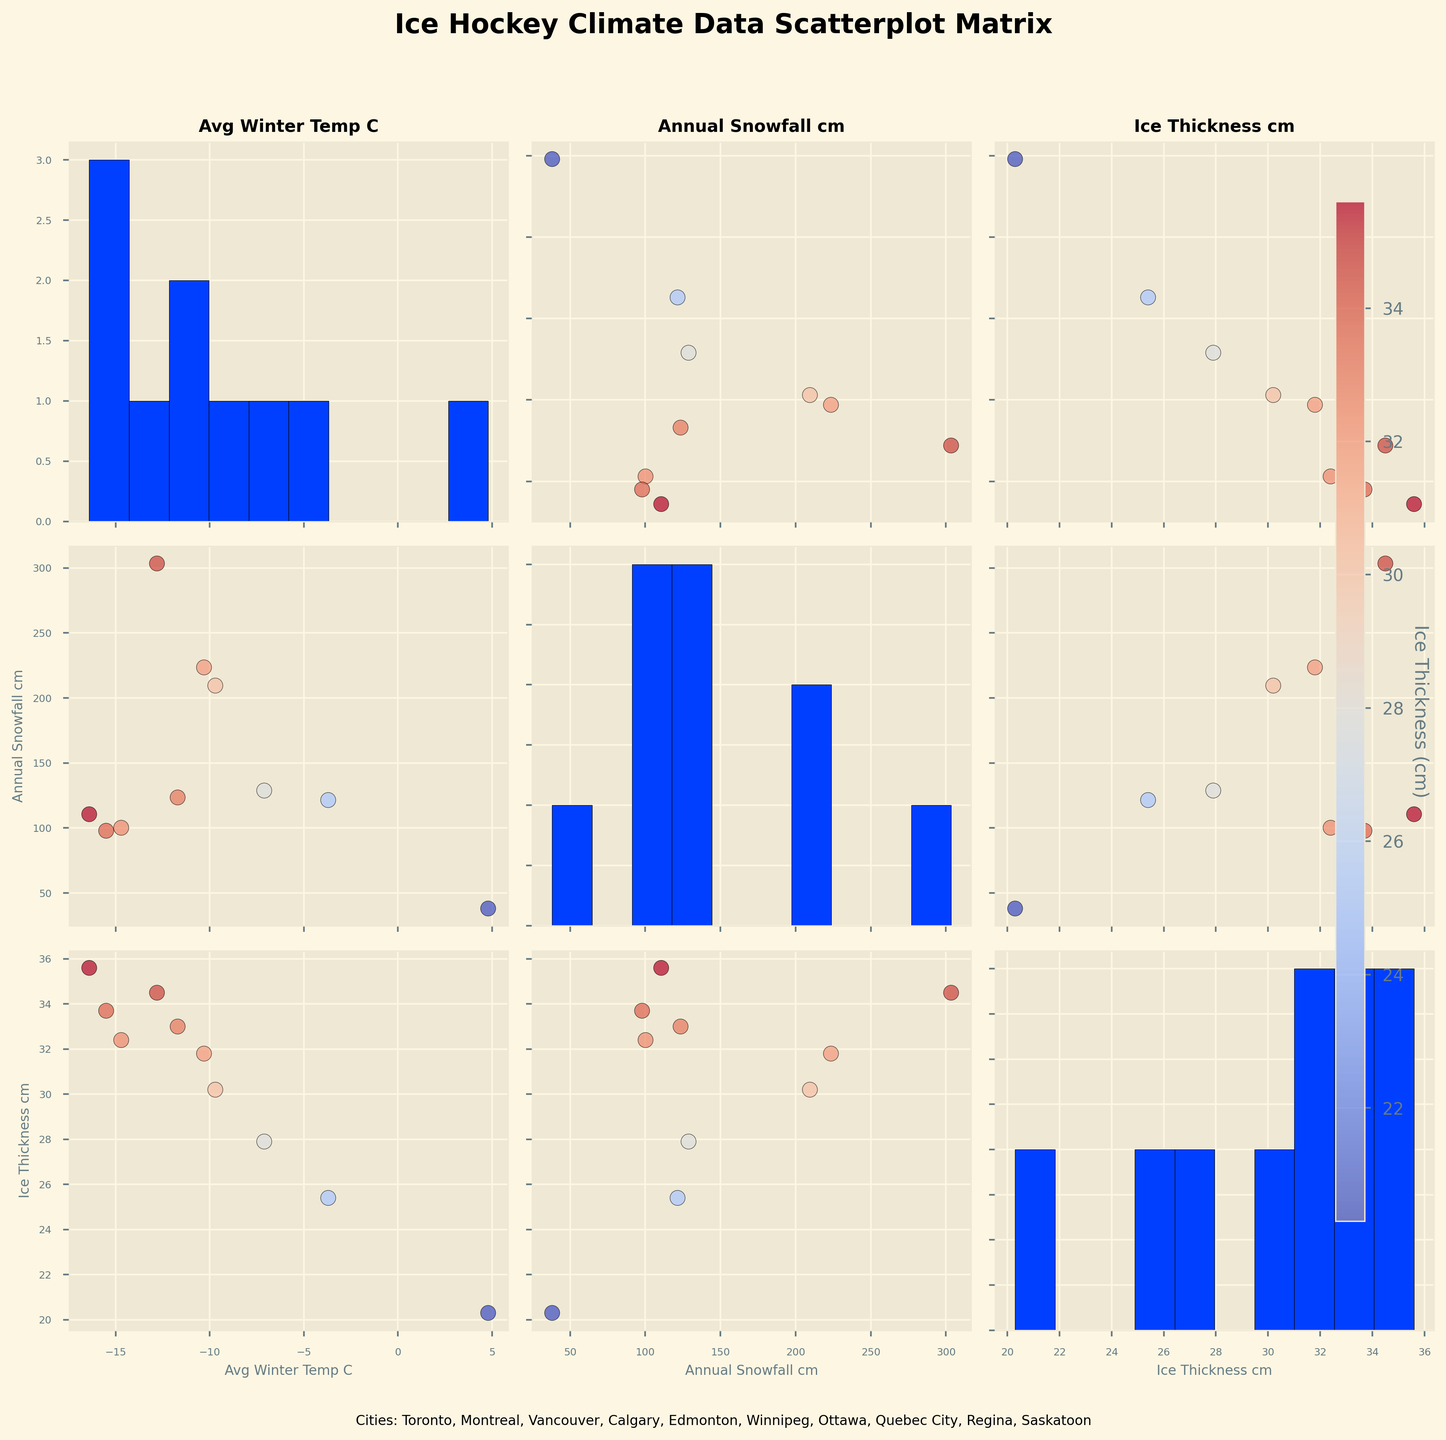What is the title of this figure? The figure title is generally located at the top of the plot and in this case, "Ice Hockey Climate Data Scatterplot Matrix" should be written there.
Answer: Ice Hockey Climate Data Scatterplot Matrix How many variables are displayed in the scatterplot matrix? The matrix plots relationships between three variables, as indicated by the labels on the axes: Avg Winter Temp (C), Annual Snowfall (cm), and Ice Thickness (cm).
Answer: 3 Which city has the highest average winter temperature? Look at the Avg Winter Temp (C) histogram in the scatterplot matrix and see that Vancouver has the highest average winter temperature, as noted by its highest position in the chart.
Answer: Vancouver Which city has the most annual snowfall? Refer to the histogram of Annual Snowfall (cm) and find the tallest bar, which represents Quebec City having the highest annual snowfall.
Answer: Quebec City What is the average ice thickness for the listed cities? To find the average, sum up the ice thickness of all cities and divide by the number of cities. The values are (25.4 + 30.2 + 20.3 + 27.9 + 33.0 + 35.6 + 31.8 + 34.5 + 32.4 + 33.7), which sum to 305.8. Dividing by 10 cities gives 305.8 / 10 = 30.58.
Answer: 30.58 cm Is there a city with both below-average winter temperatures and above-average snowfall? First, calculate the average Avg Winter Temp (C) (-3.7 - 9.7 + 4.8 - 7.1 - 11.7 - 16.4 - 10.3 - 12.8 - 14.7 - 15.5) / 10 = -9.71 and average Annual Snowfall (cm) (121.5 + 209.5 + 38.1 + 128.8 + 123.5 + 110.6 + 223.5 + 303.4 + 100.2 + 97.9) / 10 = 145.7. Then identify cities fitting both criteria: for example, Ottawa, with an Avg Winter Temp of -10.3 and Annual Snowfall of 223.5 cm.
Answer: Ottawa Compare Calgary and Winnipeg in terms of ice thickness. Which has greater ice thickness? Refer to the scatterplot points for Calgary and Winnipeg in the Ice Thickness (cm) histograms. Winnipeg has a value of 35.6 cm while Calgary has 27.9 cm. Therefore, Winnipeg has greater ice thickness.
Answer: Winnipeg Do colder cities generally have thicker ice? Observing the scatterplots comparing Avg Winter Temp (C) and Ice Thickness (cm), a trend is visible where cities with lower temperatures tend to have higher ice thickness values.
Answer: Yes What relationship, if any, is evident between annual snowfall and ice thickness? By examining the scatterplot of Annual Snowfall (cm) versus Ice Thickness (cm), a positive correlation can be observed, indicating that cities with higher snowfall typically have thicker ice.
Answer: Positive correlation Which city has the least snowfall and how does it compare in terms of ice thickness with the city with the most snowfall? Vancouver has the least snowfall (38.1 cm), and Quebec City has the most snowfall (303.4 cm). Comparing their ice thickness values, Vancouver has 20.3 cm of ice thickness whereas Quebec City has 34.5 cm.
Answer: Vancouver: 20.3 cm, Quebec City: 34.5 cm 